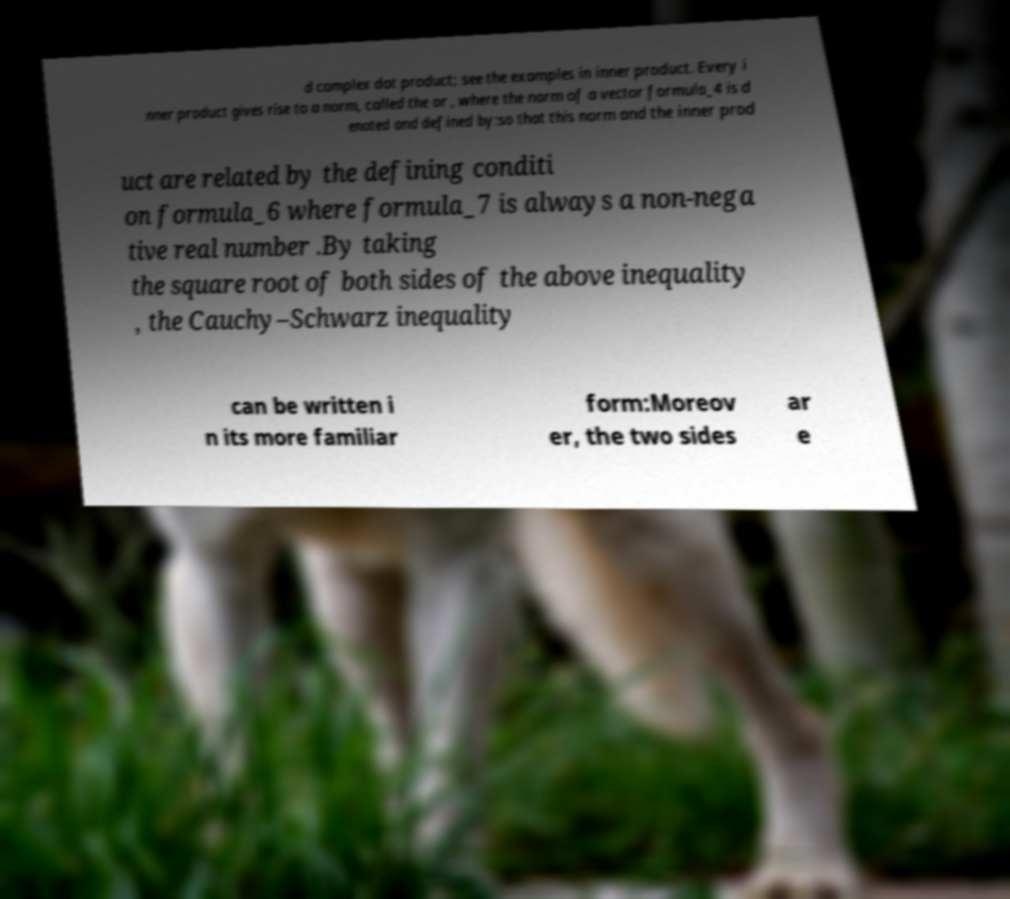Can you accurately transcribe the text from the provided image for me? d complex dot product; see the examples in inner product. Every i nner product gives rise to a norm, called the or , where the norm of a vector formula_4 is d enoted and defined by:so that this norm and the inner prod uct are related by the defining conditi on formula_6 where formula_7 is always a non-nega tive real number .By taking the square root of both sides of the above inequality , the Cauchy–Schwarz inequality can be written i n its more familiar form:Moreov er, the two sides ar e 